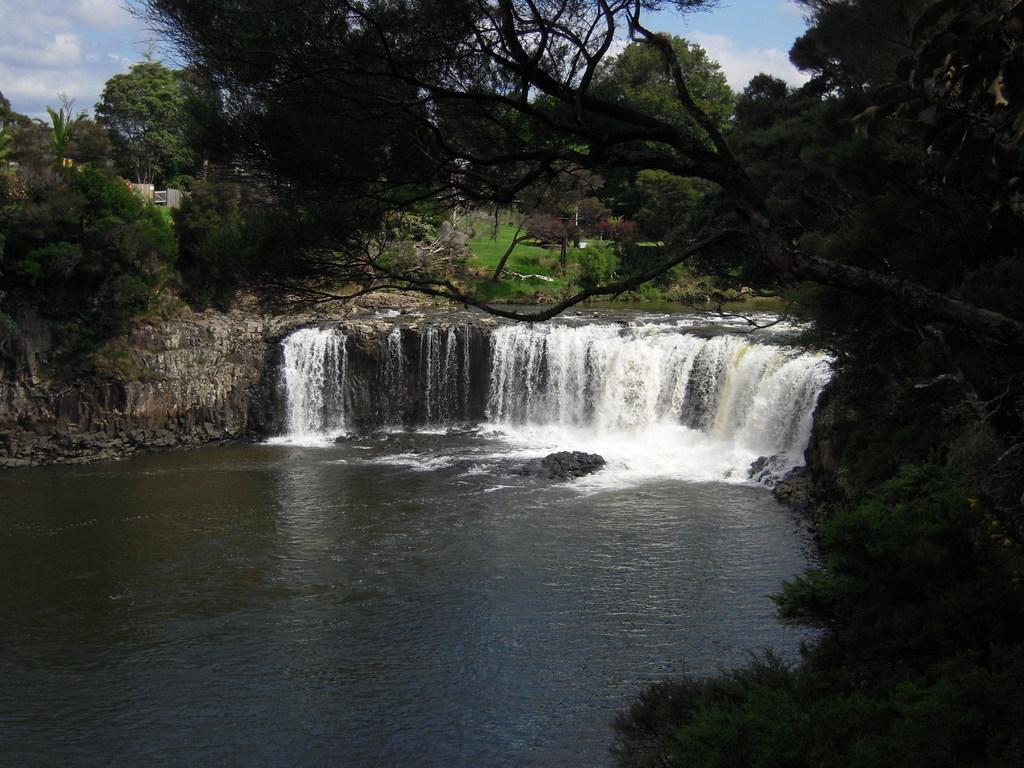How would you summarize this image in a sentence or two? Here in this picture we can see a river, as we can see a waterfall from the rock stones present in the middle over there and we can see plants and trees present all over there and we can see clouds in the sky. 